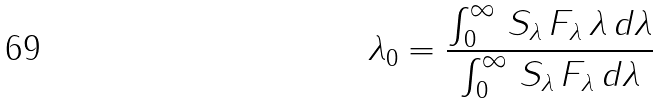<formula> <loc_0><loc_0><loc_500><loc_500>\lambda _ { 0 } = \frac { \int _ { 0 } ^ { \infty } \, S _ { \lambda } \, F _ { \lambda } \, \lambda \, d \lambda } { \int _ { 0 } ^ { \infty } \, S _ { \lambda } \, F _ { \lambda } \, d \lambda }</formula> 